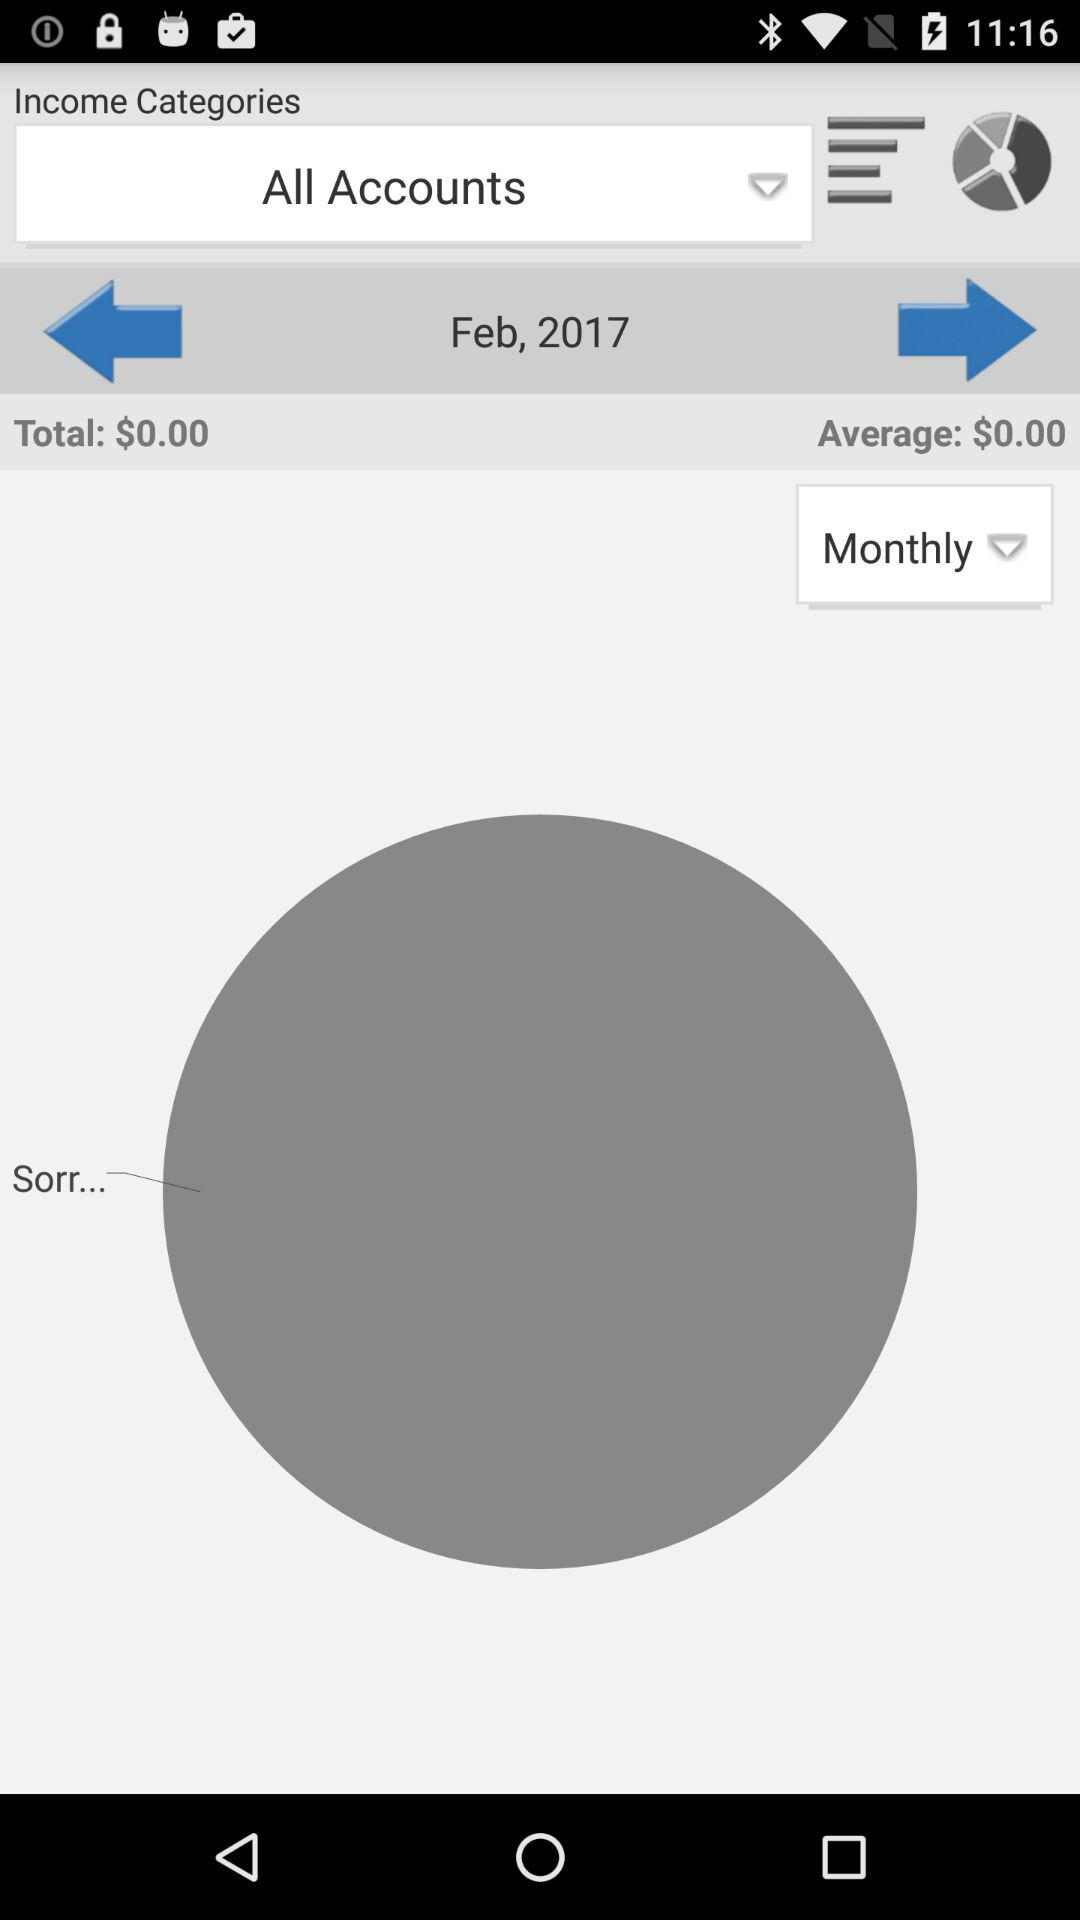What is the total income for Feb, 2017?
Answer the question using a single word or phrase. $0.00 